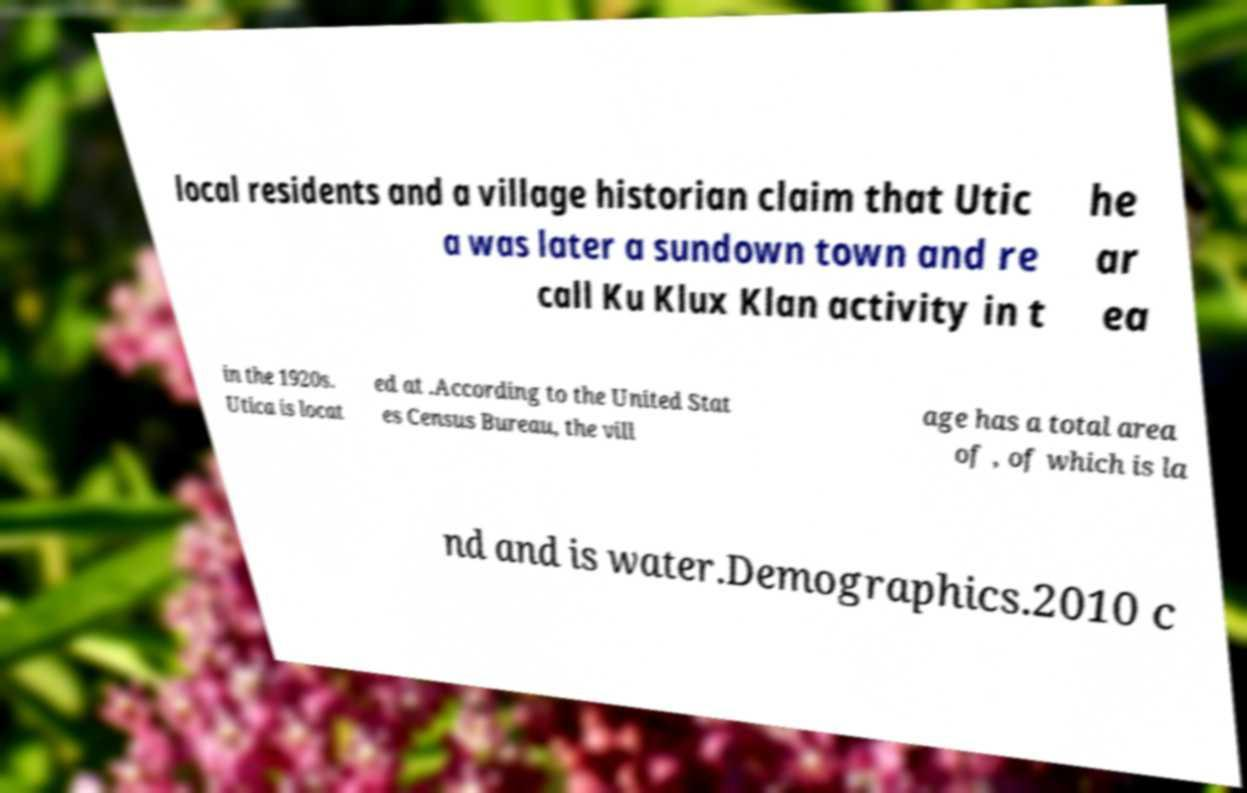There's text embedded in this image that I need extracted. Can you transcribe it verbatim? local residents and a village historian claim that Utic a was later a sundown town and re call Ku Klux Klan activity in t he ar ea in the 1920s. Utica is locat ed at .According to the United Stat es Census Bureau, the vill age has a total area of , of which is la nd and is water.Demographics.2010 c 